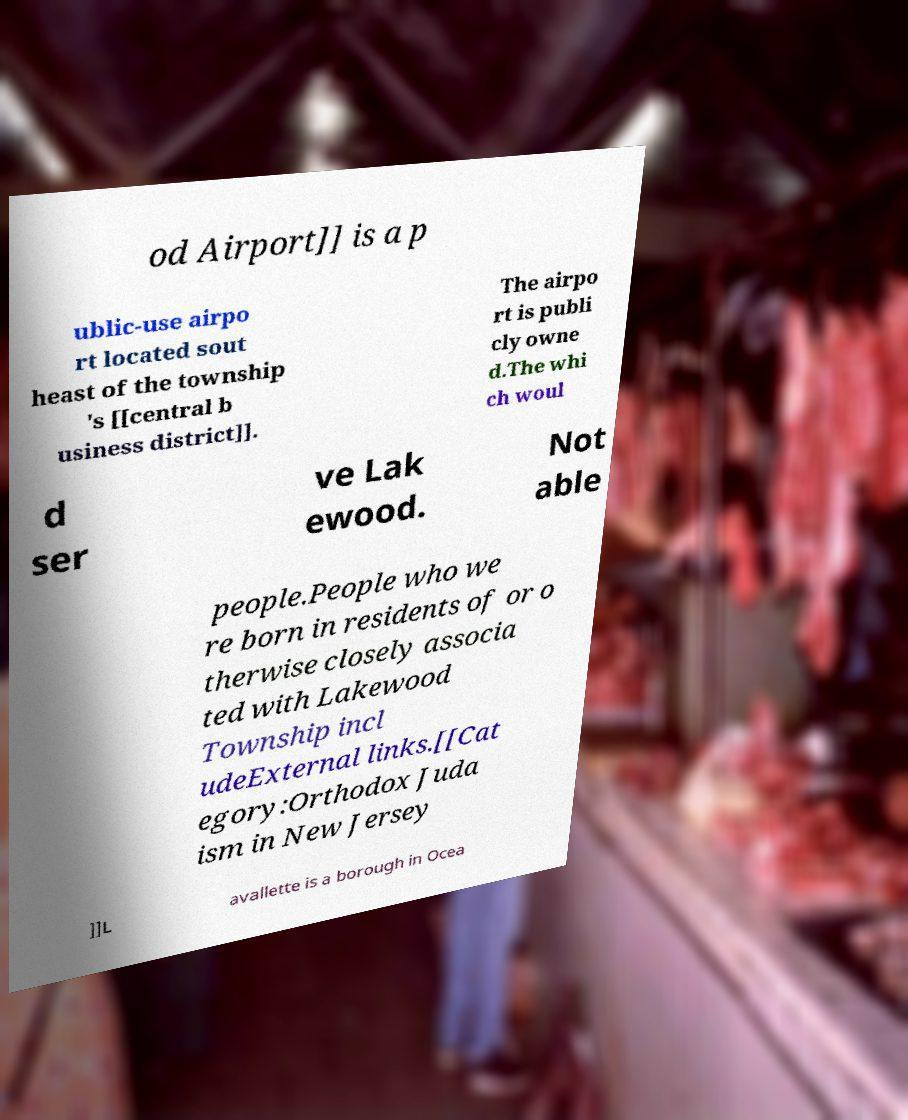Can you accurately transcribe the text from the provided image for me? od Airport]] is a p ublic-use airpo rt located sout heast of the township 's [[central b usiness district]]. The airpo rt is publi cly owne d.The whi ch woul d ser ve Lak ewood. Not able people.People who we re born in residents of or o therwise closely associa ted with Lakewood Township incl udeExternal links.[[Cat egory:Orthodox Juda ism in New Jersey ]]L avallette is a borough in Ocea 